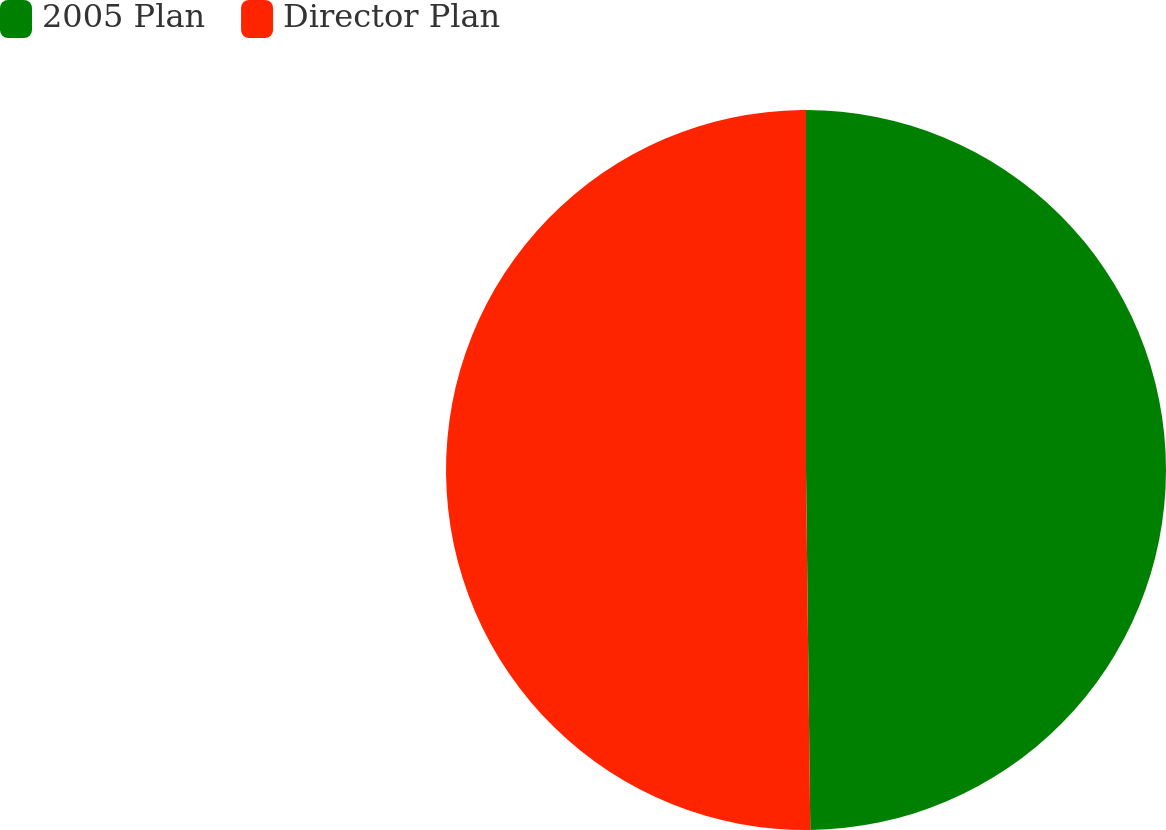<chart> <loc_0><loc_0><loc_500><loc_500><pie_chart><fcel>2005 Plan<fcel>Director Plan<nl><fcel>49.81%<fcel>50.19%<nl></chart> 